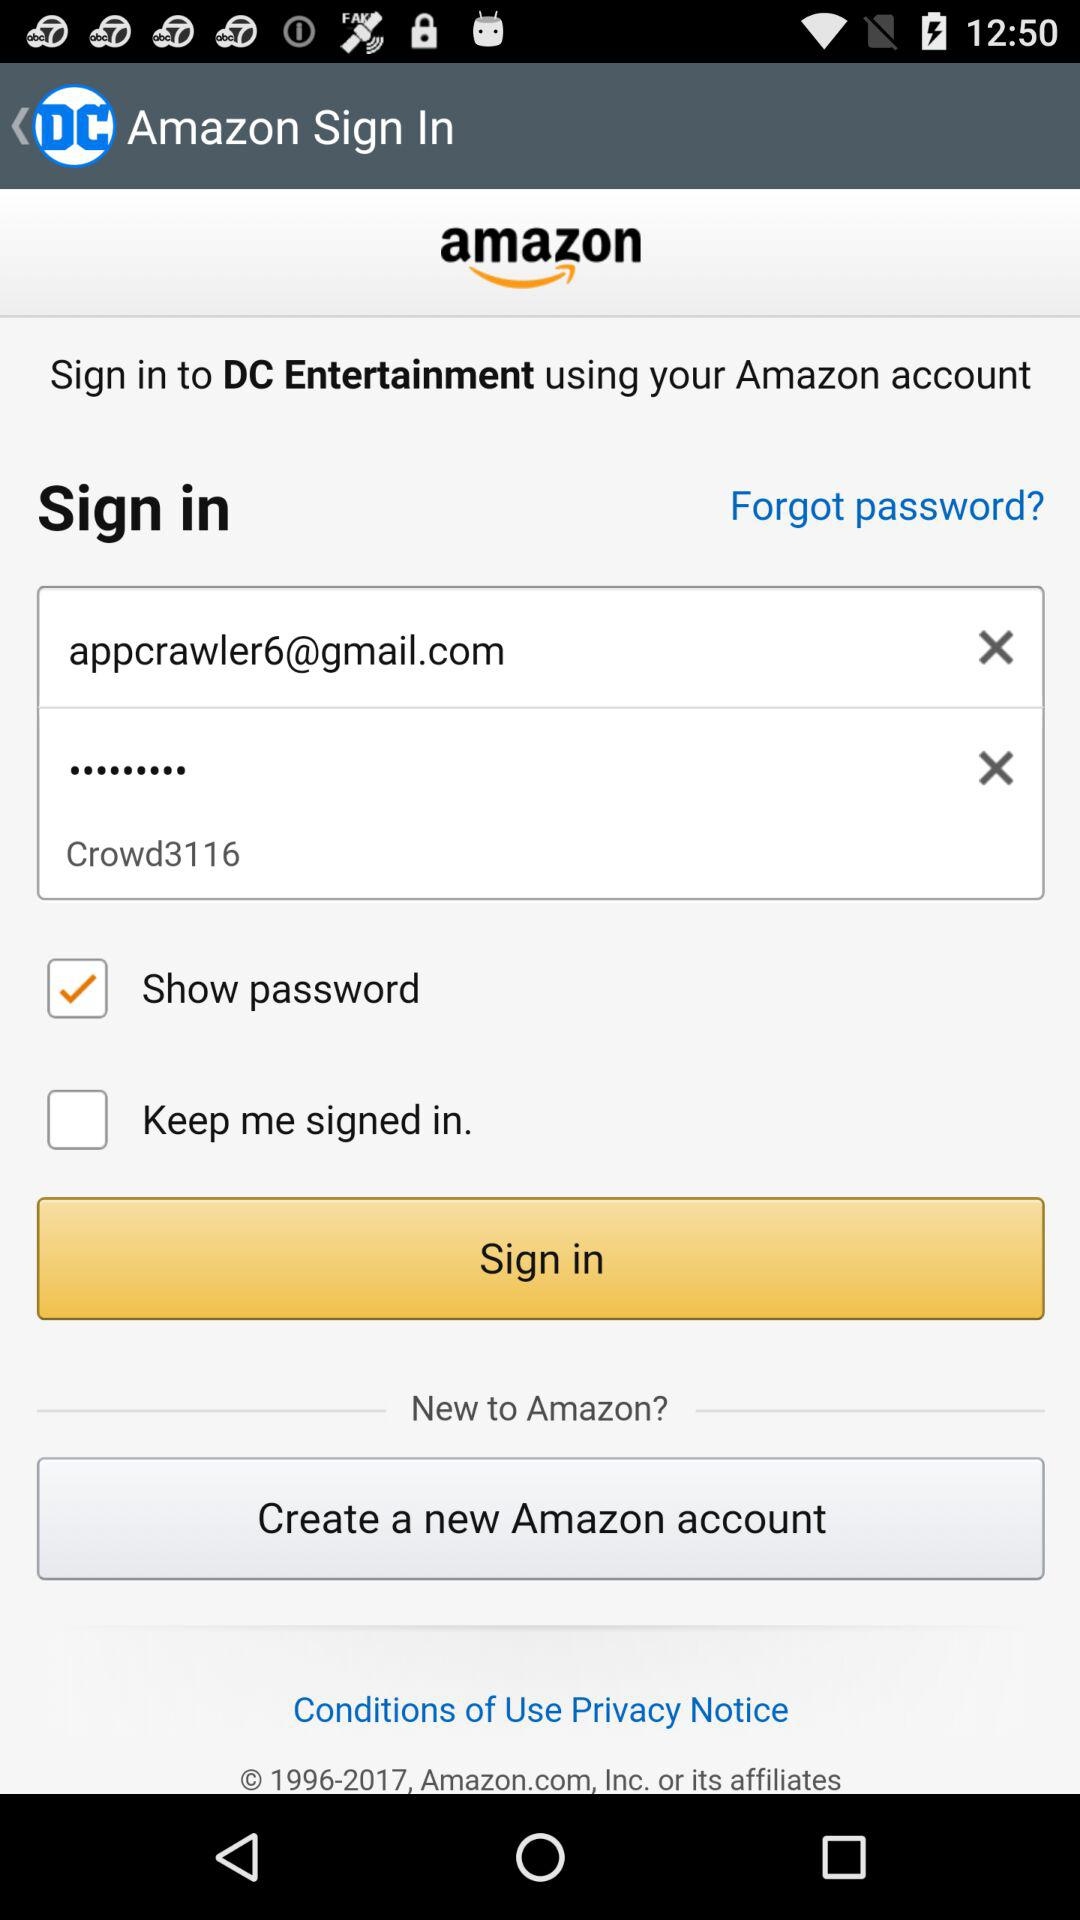Which account is used to sign in to "DC Entertainment"? The account is "Amazon". 